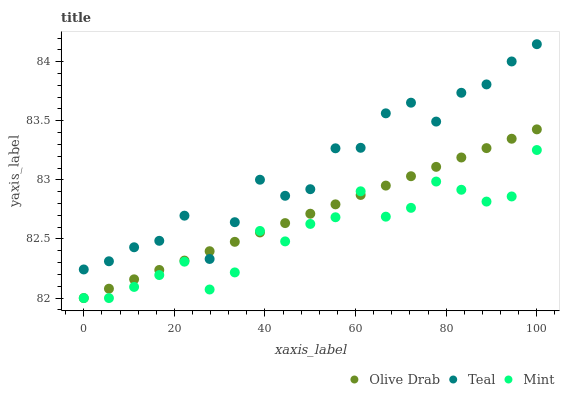Does Mint have the minimum area under the curve?
Answer yes or no. Yes. Does Teal have the maximum area under the curve?
Answer yes or no. Yes. Does Olive Drab have the minimum area under the curve?
Answer yes or no. No. Does Olive Drab have the maximum area under the curve?
Answer yes or no. No. Is Olive Drab the smoothest?
Answer yes or no. Yes. Is Teal the roughest?
Answer yes or no. Yes. Is Teal the smoothest?
Answer yes or no. No. Is Olive Drab the roughest?
Answer yes or no. No. Does Mint have the lowest value?
Answer yes or no. Yes. Does Teal have the lowest value?
Answer yes or no. No. Does Teal have the highest value?
Answer yes or no. Yes. Does Olive Drab have the highest value?
Answer yes or no. No. Is Mint less than Teal?
Answer yes or no. Yes. Is Teal greater than Mint?
Answer yes or no. Yes. Does Mint intersect Olive Drab?
Answer yes or no. Yes. Is Mint less than Olive Drab?
Answer yes or no. No. Is Mint greater than Olive Drab?
Answer yes or no. No. Does Mint intersect Teal?
Answer yes or no. No. 